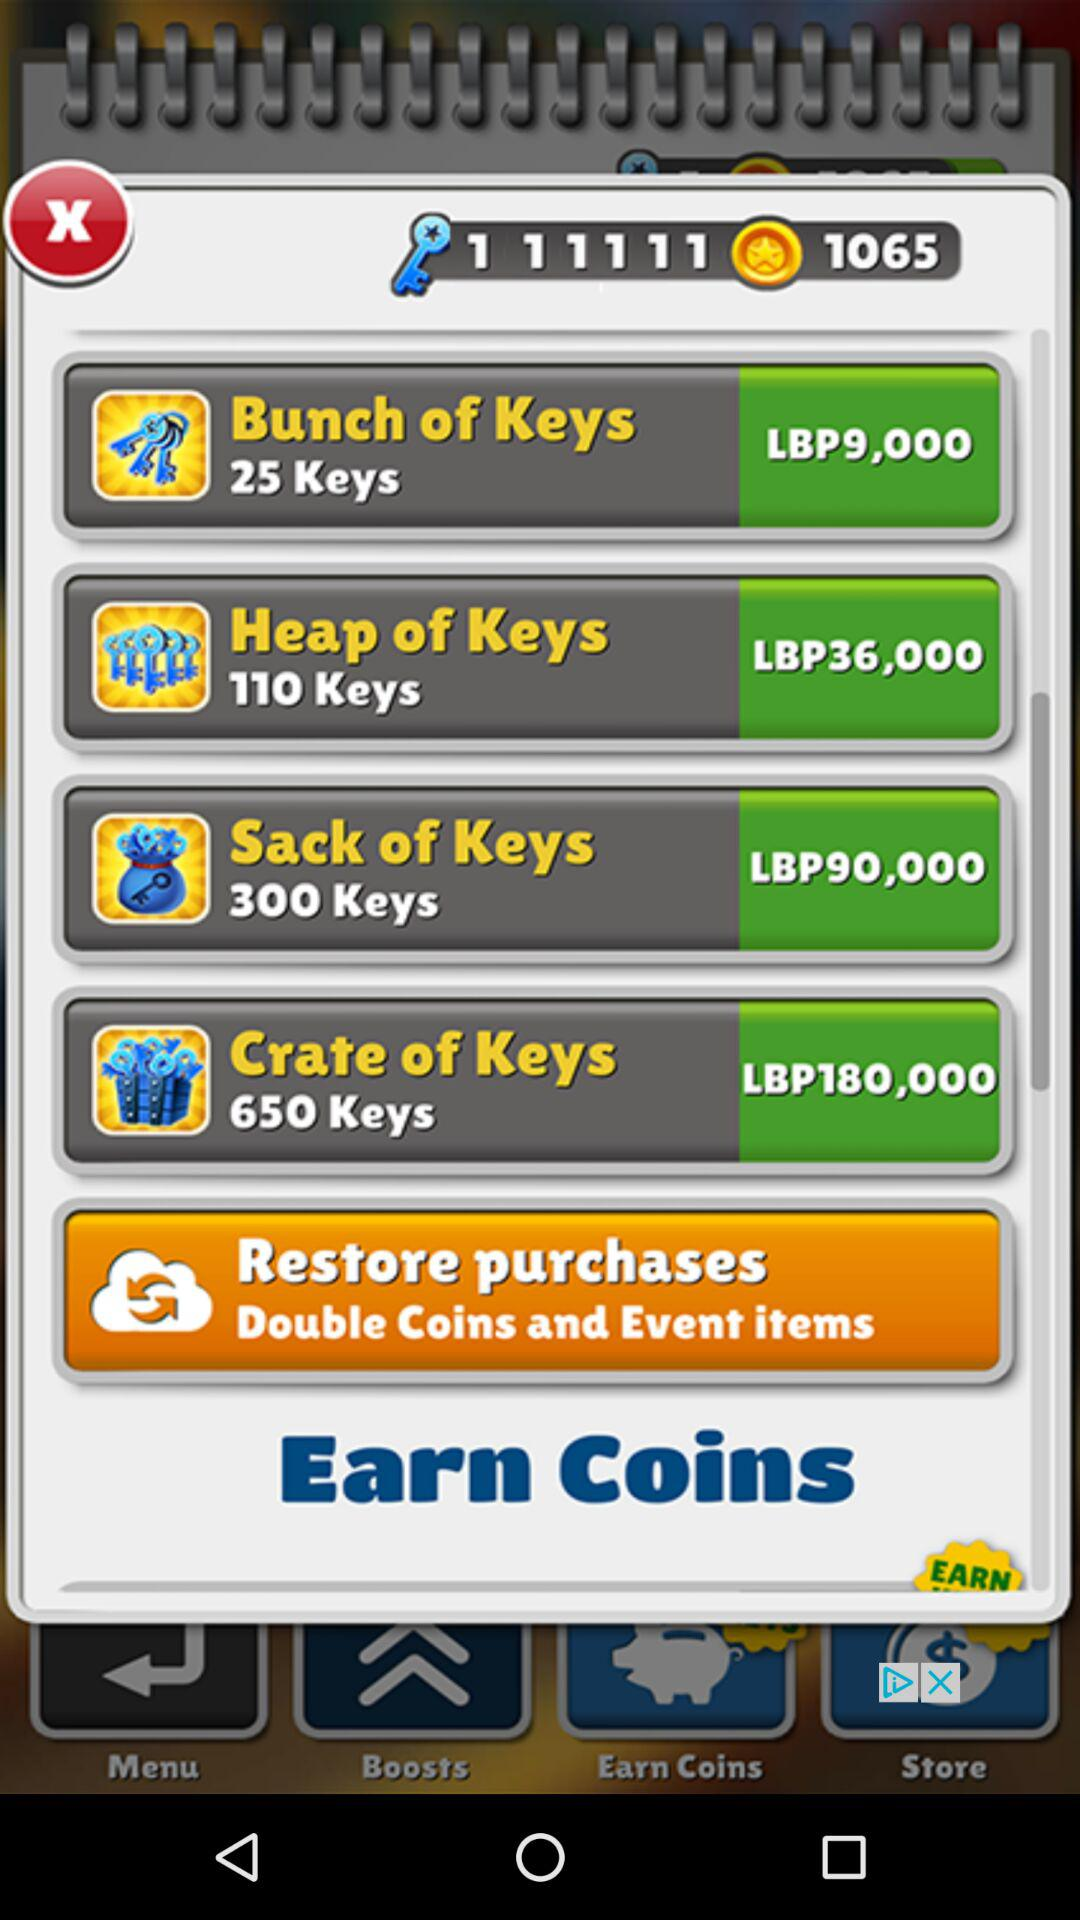How many coins in total are earned? There are 1065 coins earned. 